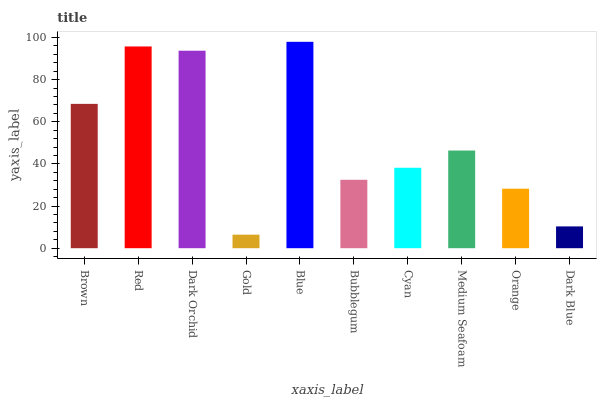Is Gold the minimum?
Answer yes or no. Yes. Is Blue the maximum?
Answer yes or no. Yes. Is Red the minimum?
Answer yes or no. No. Is Red the maximum?
Answer yes or no. No. Is Red greater than Brown?
Answer yes or no. Yes. Is Brown less than Red?
Answer yes or no. Yes. Is Brown greater than Red?
Answer yes or no. No. Is Red less than Brown?
Answer yes or no. No. Is Medium Seafoam the high median?
Answer yes or no. Yes. Is Cyan the low median?
Answer yes or no. Yes. Is Blue the high median?
Answer yes or no. No. Is Red the low median?
Answer yes or no. No. 